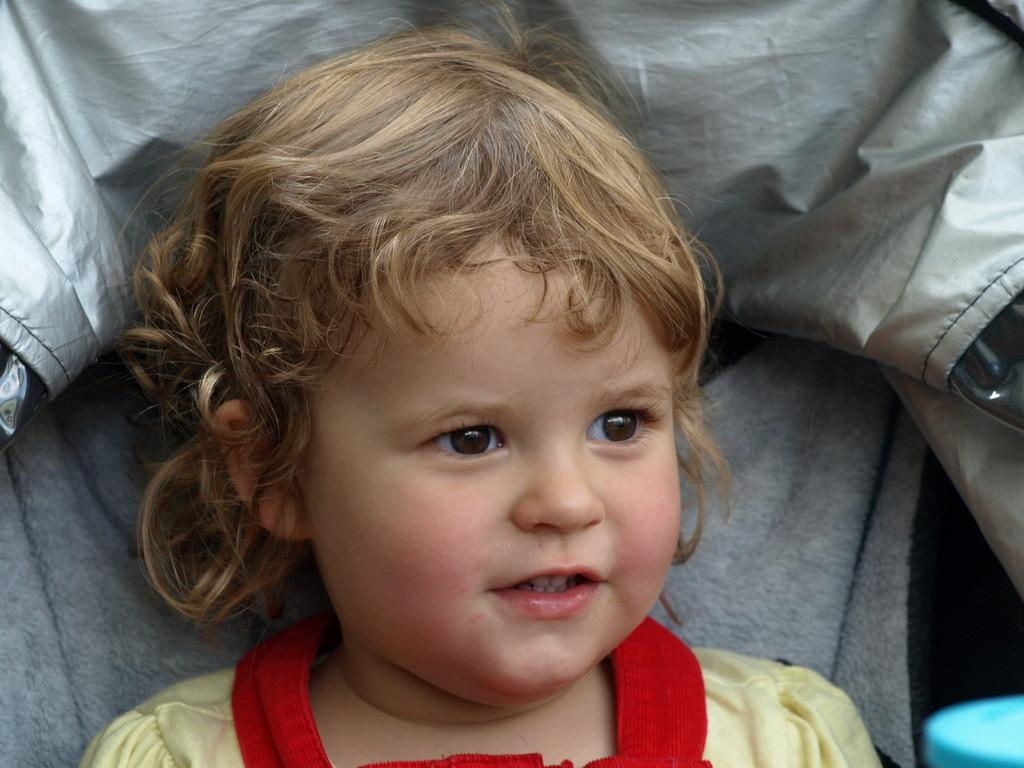What is the main subject of the image? There is a baby in the image. What is the baby wearing? The baby is wearing a red and yellow dress. Can you describe any other objects in the image? There is a blue object in the image. What can be seen in the background of the image? There is an ash-colored cloth in the background of the image. How many heads of lettuce can be seen in the image? There are no heads of lettuce present in the image. What type of dime is visible in the image? There is no dime visible in the image. 